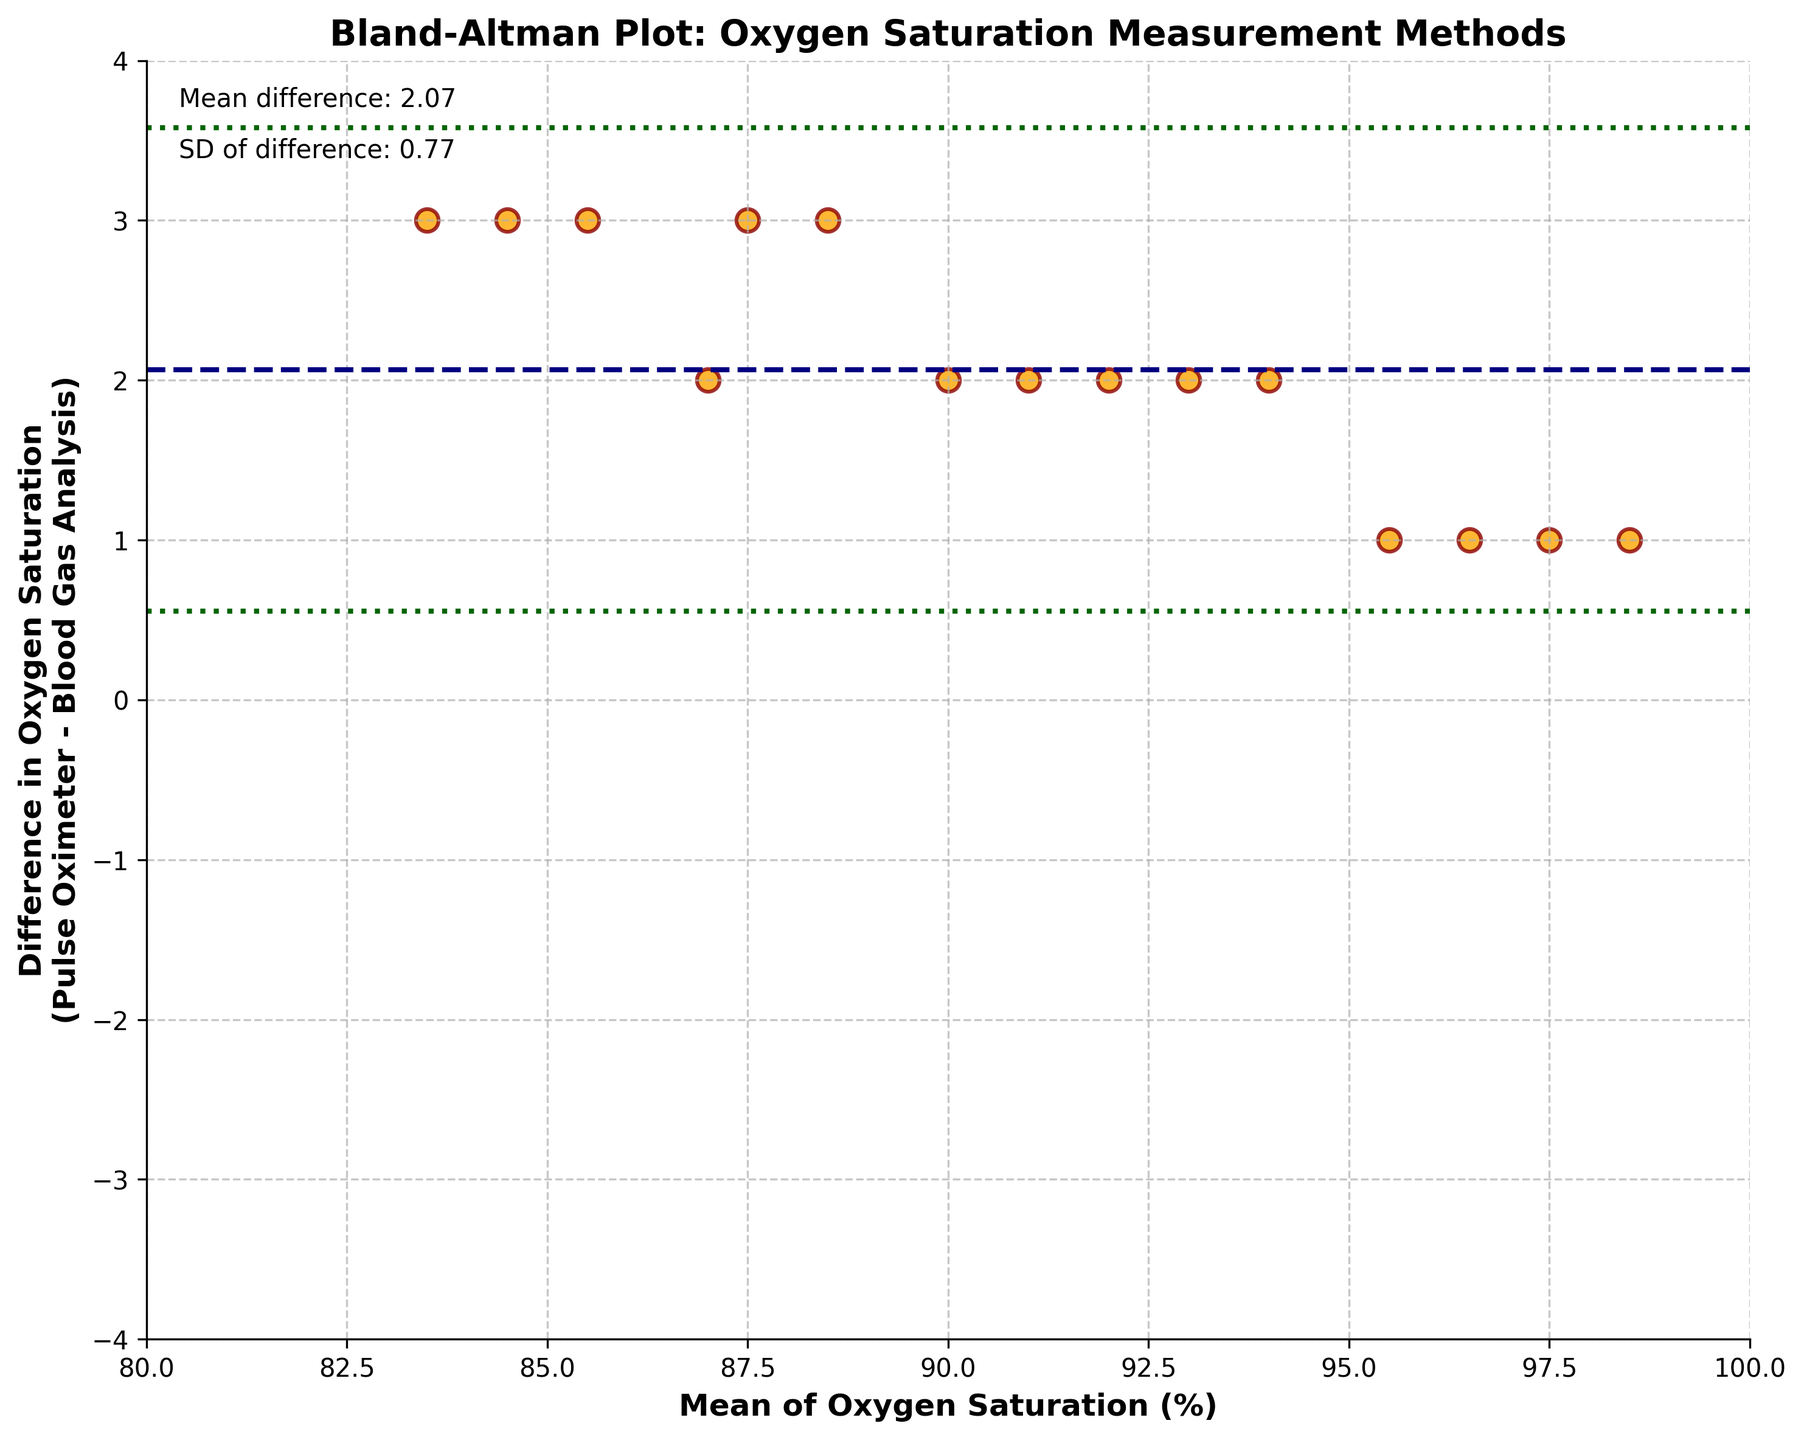What is the title of the figure? The title of the figure is written at the top of the plot.
Answer: Bland-Altman Plot: Oxygen Saturation Measurement Methods What are the axes labels of the plot? The x-axis label is "Mean of Oxygen Saturation (%)", and the y-axis label is "Difference in Oxygen Saturation (Pulse Oximeter - Blood Gas Analysis)".
Answer: Mean of Oxygen Saturation (%); Difference in Oxygen Saturation (Pulse Oximeter - Blood Gas Analysis) How many data points are displayed in the plot? Count the number of orange dots representing the data points on the figure. There are 15 data points shown.
Answer: 15 What is the mean difference in oxygen saturation between the two measurement methods? The mean difference is indicated by the horizontal dashed line labeled "Mean difference" in the figure. The value is around -0.87.
Answer: -0.87 What is the standard deviation of the differences in oxygen saturation between the two measurement methods? The standard deviation of the differences is given near the "Mean difference" text in the figure. It is approximately 1.27.
Answer: 1.27 Are there any points that fall outside the 95% limits of agreement? The 95% limits of agreement are represented by the dotted lines. Check if any points are outside these lines. No points fall outside these limits.
Answer: No What is the highest mean oxygen saturation value you can observe in the plot? Locate the highest value on the x-axis where the data points are plotted. The highest mean value is close to 98.5.
Answer: 98.5 What color are the data points in the plot? The data points are colored orange.
Answer: Orange What does the navy horizontal dashed line represent? The navy dashed line represents the mean difference between the oxygen saturation levels measured by the Pulse Oximeter and Blood Gas Analysis.
Answer: Mean difference What's the lowest difference observed in oxygen saturation levels between the two methods? Identify the lowest y-value among the data points. The lowest difference observed is around -3.
Answer: -3 What is the difference in oxygen saturation for the data point with a mean value around 97? Find the data point near the mean value of 97 on the x-axis and check its y-axis coordinate. The difference is approximately 1.
Answer: 1 What is the primary purpose of this Bland-Altman plot? A Bland-Altman plot is used to assess the agreement between two different measurement methods.
Answer: Assess agreement between methods 